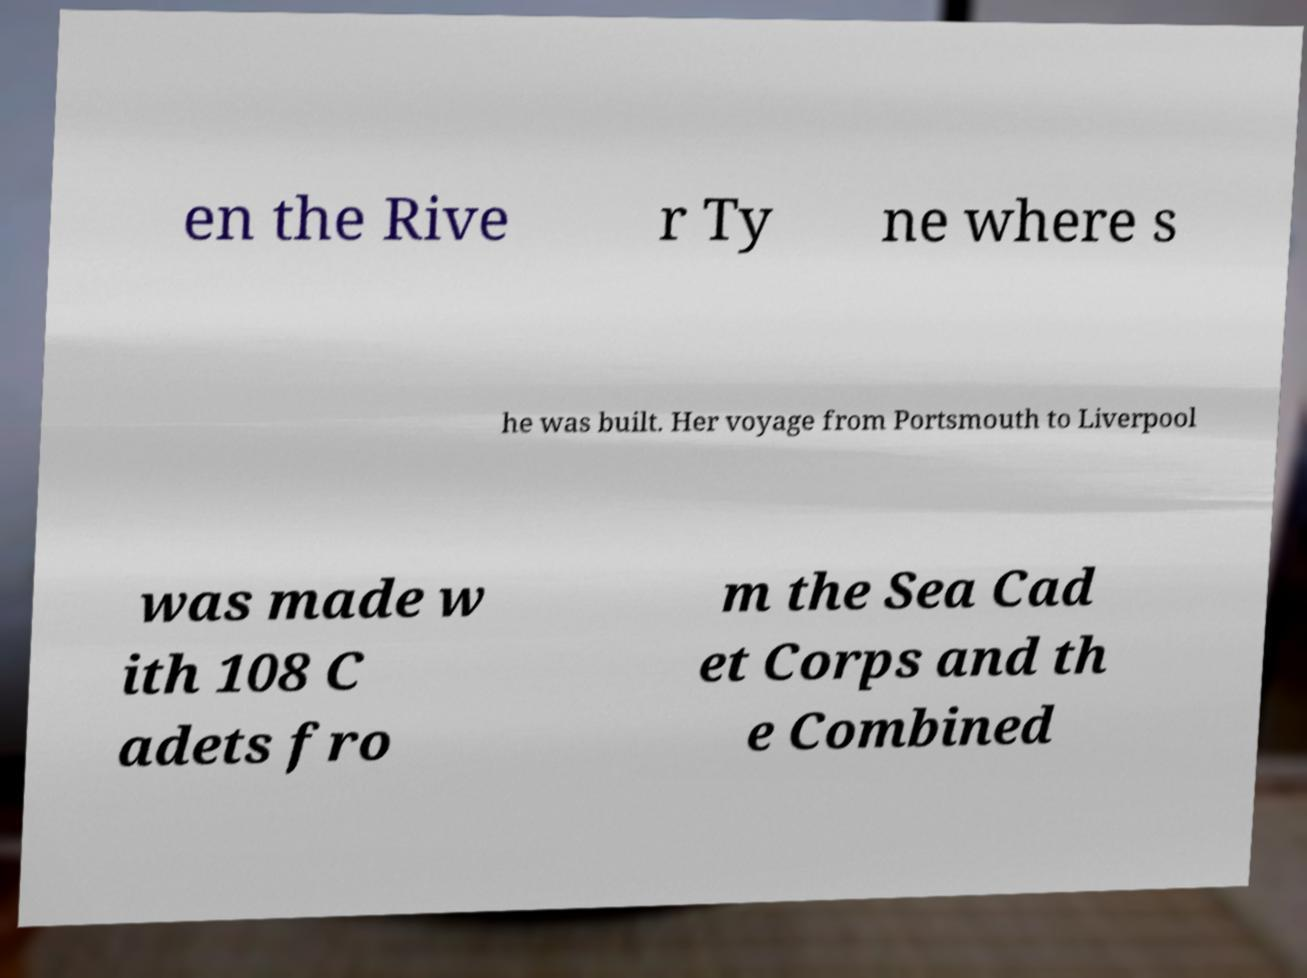For documentation purposes, I need the text within this image transcribed. Could you provide that? en the Rive r Ty ne where s he was built. Her voyage from Portsmouth to Liverpool was made w ith 108 C adets fro m the Sea Cad et Corps and th e Combined 